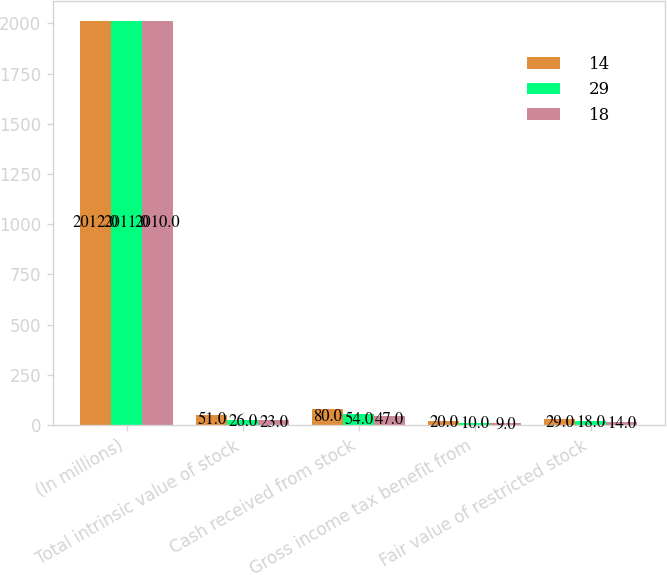Convert chart to OTSL. <chart><loc_0><loc_0><loc_500><loc_500><stacked_bar_chart><ecel><fcel>(In millions)<fcel>Total intrinsic value of stock<fcel>Cash received from stock<fcel>Gross income tax benefit from<fcel>Fair value of restricted stock<nl><fcel>14<fcel>2012<fcel>51<fcel>80<fcel>20<fcel>29<nl><fcel>29<fcel>2011<fcel>26<fcel>54<fcel>10<fcel>18<nl><fcel>18<fcel>2010<fcel>23<fcel>47<fcel>9<fcel>14<nl></chart> 